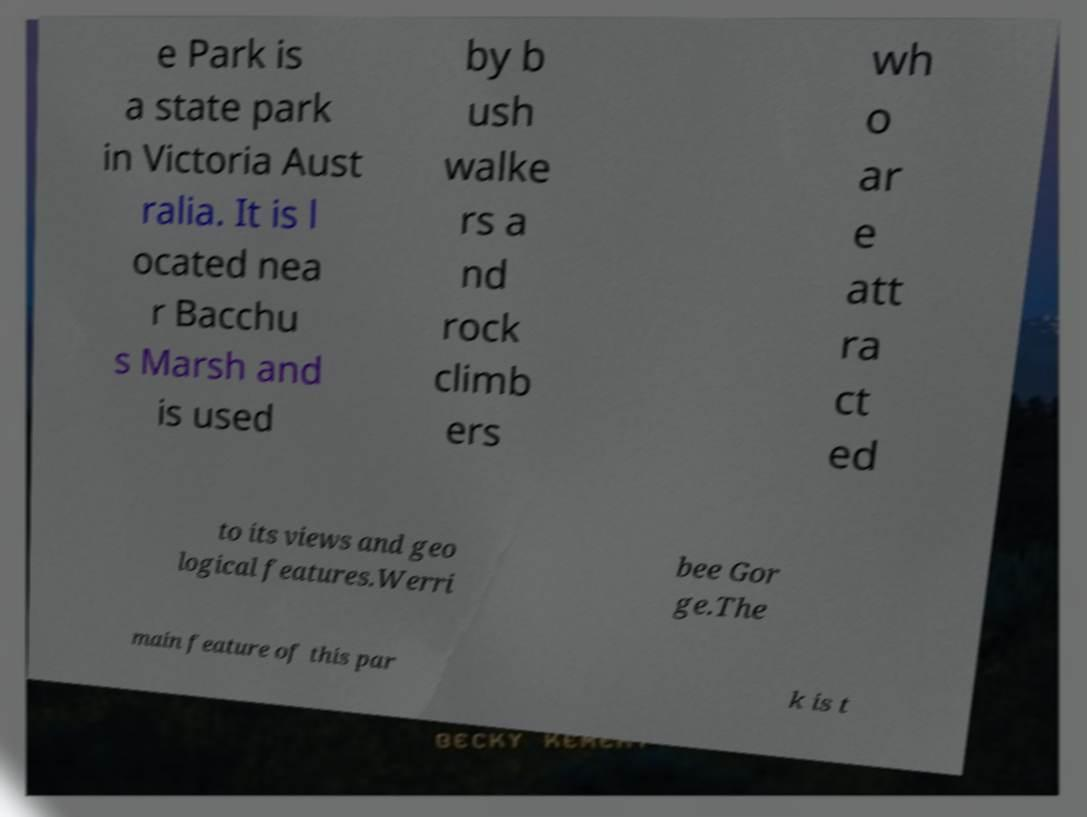Please identify and transcribe the text found in this image. e Park is a state park in Victoria Aust ralia. It is l ocated nea r Bacchu s Marsh and is used by b ush walke rs a nd rock climb ers wh o ar e att ra ct ed to its views and geo logical features.Werri bee Gor ge.The main feature of this par k is t 